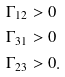Convert formula to latex. <formula><loc_0><loc_0><loc_500><loc_500>\Gamma _ { 1 2 } & > 0 \\ \Gamma _ { 3 1 } & > 0 \\ \Gamma _ { 2 3 } & > 0 .</formula> 